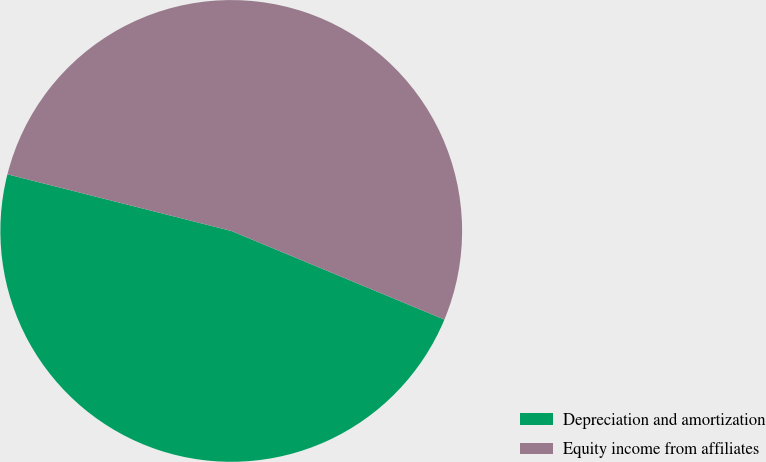Convert chart to OTSL. <chart><loc_0><loc_0><loc_500><loc_500><pie_chart><fcel>Depreciation and amortization<fcel>Equity income from affiliates<nl><fcel>47.67%<fcel>52.33%<nl></chart> 